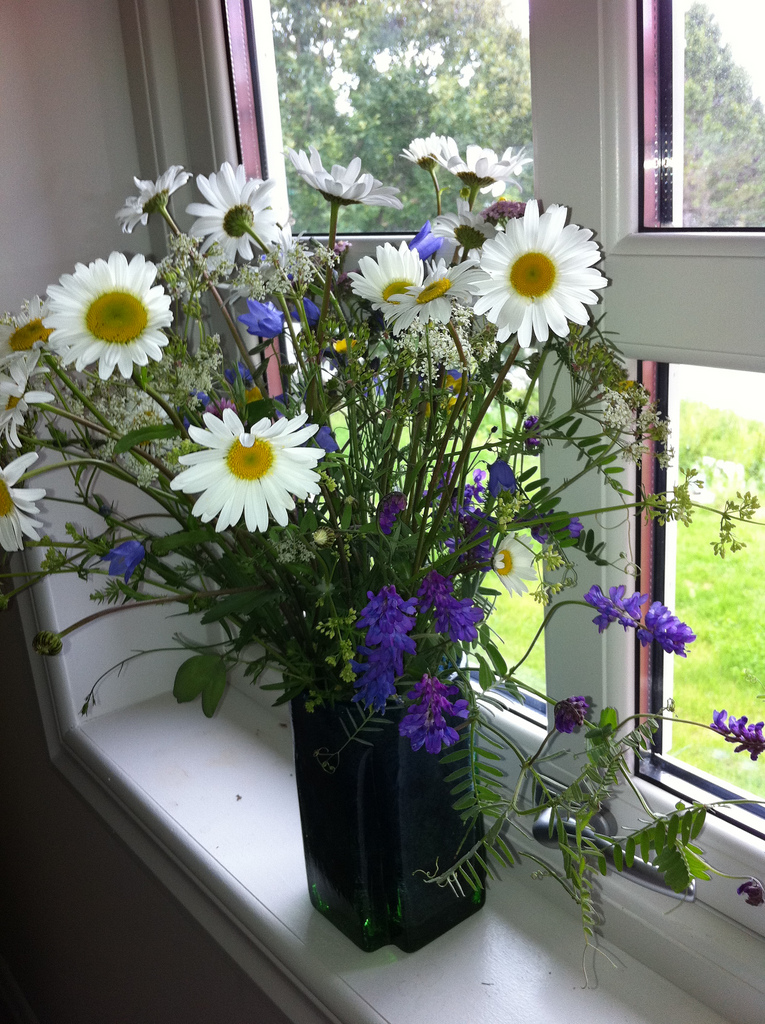Do you see either any plates or napkins? No, I do not see any plates or napkins in the image. 